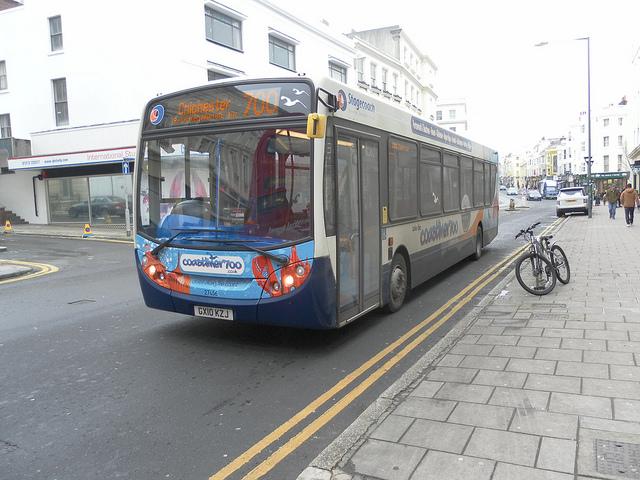Is this public or private transportation?
Write a very short answer. Public. What number is written in front of the bus?
Give a very brief answer. 700. What is the name of the town on the bus marquee?
Keep it brief. Chichester. 